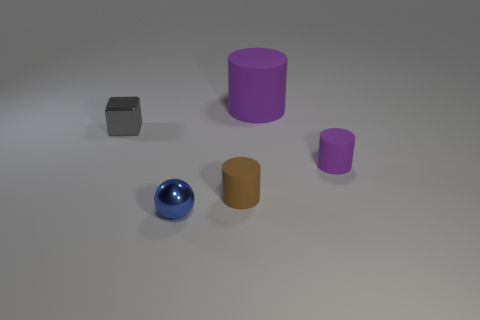Is the cube the same size as the blue metal object?
Offer a very short reply. Yes. What number of objects are large green rubber cubes or cylinders?
Keep it short and to the point. 3. What size is the thing that is left of the big object and on the right side of the blue shiny object?
Provide a succinct answer. Small. Are there fewer brown objects that are behind the small gray block than cyan shiny cubes?
Your answer should be very brief. No. The object that is made of the same material as the small blue ball is what shape?
Give a very brief answer. Cube. There is a tiny metal object that is right of the small gray metal cube; is its shape the same as the metal object behind the brown matte cylinder?
Offer a very short reply. No. Are there fewer small gray shiny objects behind the small metallic cube than large rubber objects that are to the right of the tiny blue shiny ball?
Keep it short and to the point. Yes. There is a small object that is the same color as the big object; what is its shape?
Your response must be concise. Cylinder. What number of purple rubber cylinders are the same size as the gray metallic object?
Give a very brief answer. 1. Is the material of the purple thing in front of the small metallic block the same as the small gray thing?
Ensure brevity in your answer.  No. 